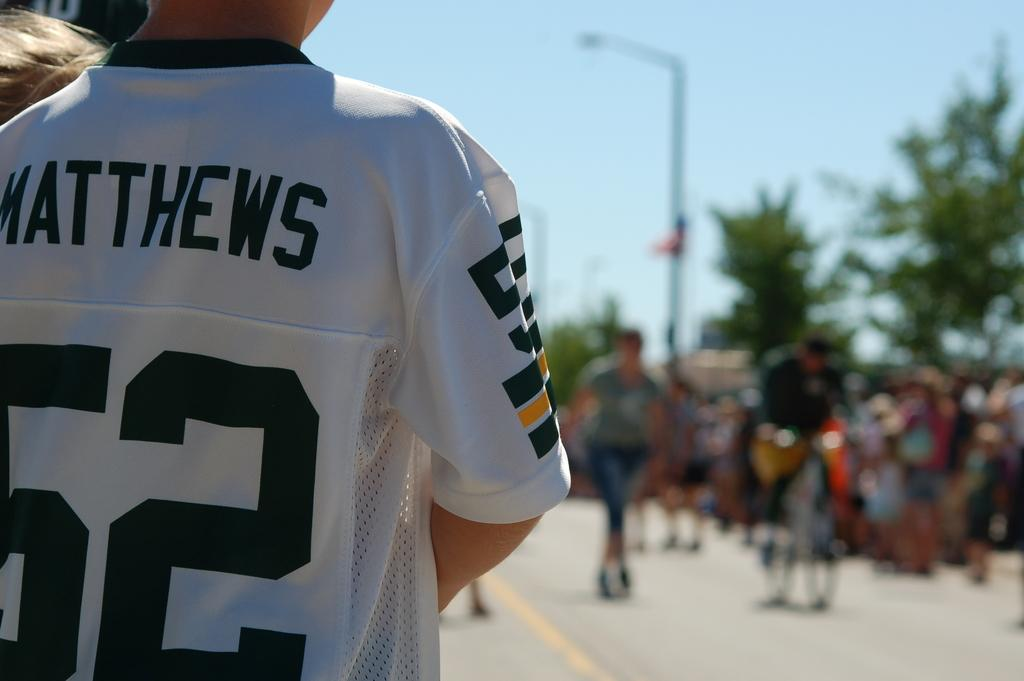<image>
Relay a brief, clear account of the picture shown. A child wearing a jersey that says 52 on it is watching a marathon. 